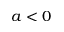<formula> <loc_0><loc_0><loc_500><loc_500>a < 0</formula> 